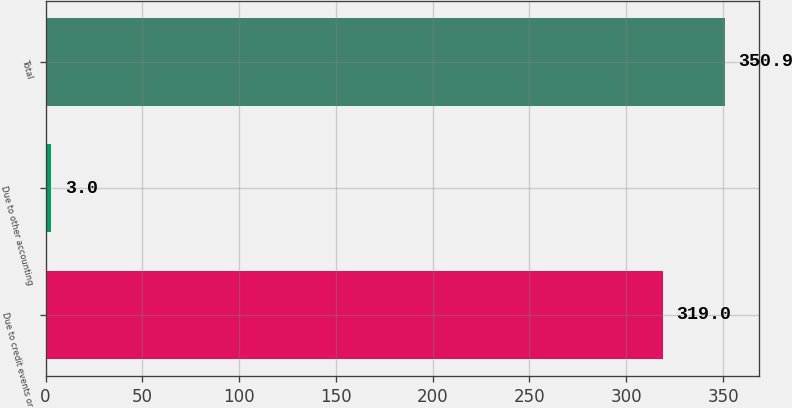<chart> <loc_0><loc_0><loc_500><loc_500><bar_chart><fcel>Due to credit events or<fcel>Due to other accounting<fcel>Total<nl><fcel>319<fcel>3<fcel>350.9<nl></chart> 